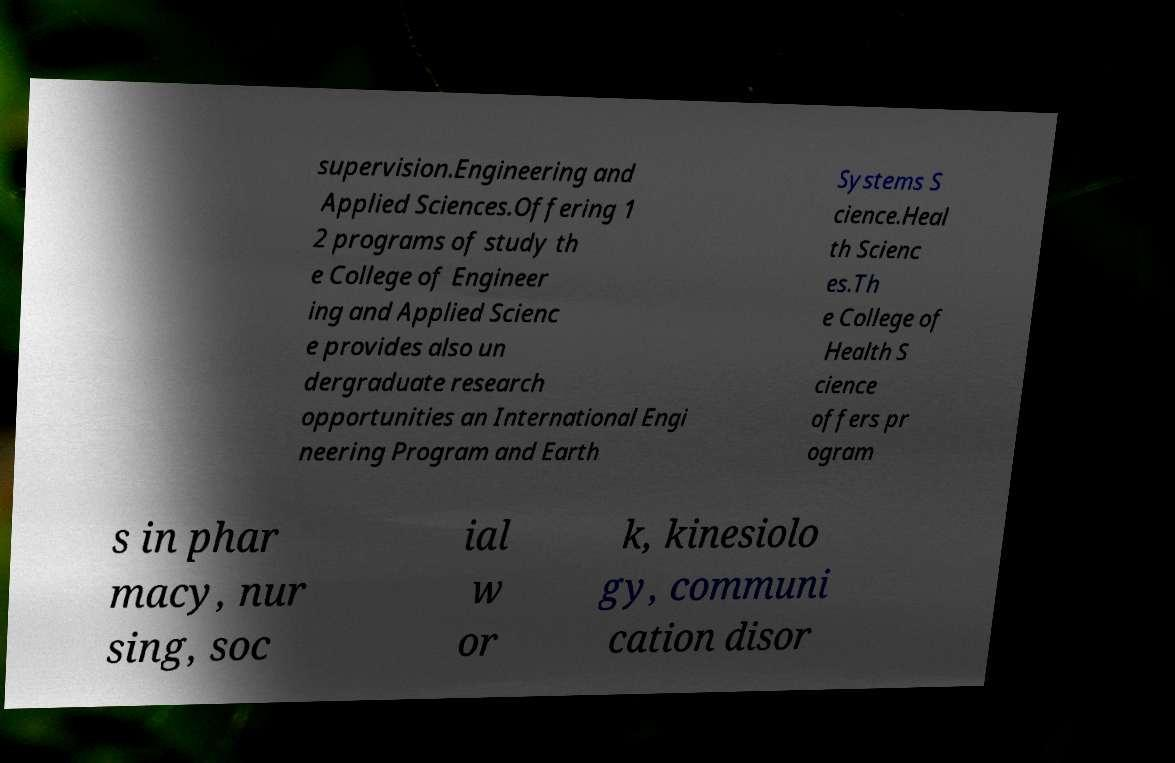I need the written content from this picture converted into text. Can you do that? supervision.Engineering and Applied Sciences.Offering 1 2 programs of study th e College of Engineer ing and Applied Scienc e provides also un dergraduate research opportunities an International Engi neering Program and Earth Systems S cience.Heal th Scienc es.Th e College of Health S cience offers pr ogram s in phar macy, nur sing, soc ial w or k, kinesiolo gy, communi cation disor 